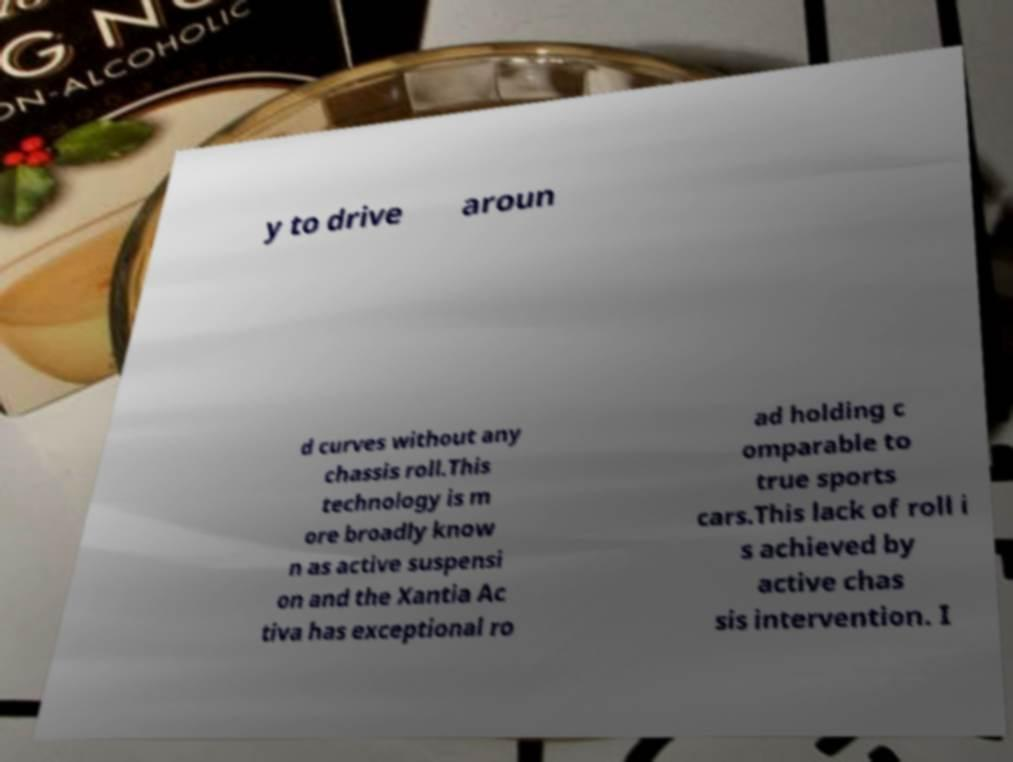Could you extract and type out the text from this image? y to drive aroun d curves without any chassis roll.This technology is m ore broadly know n as active suspensi on and the Xantia Ac tiva has exceptional ro ad holding c omparable to true sports cars.This lack of roll i s achieved by active chas sis intervention. I 